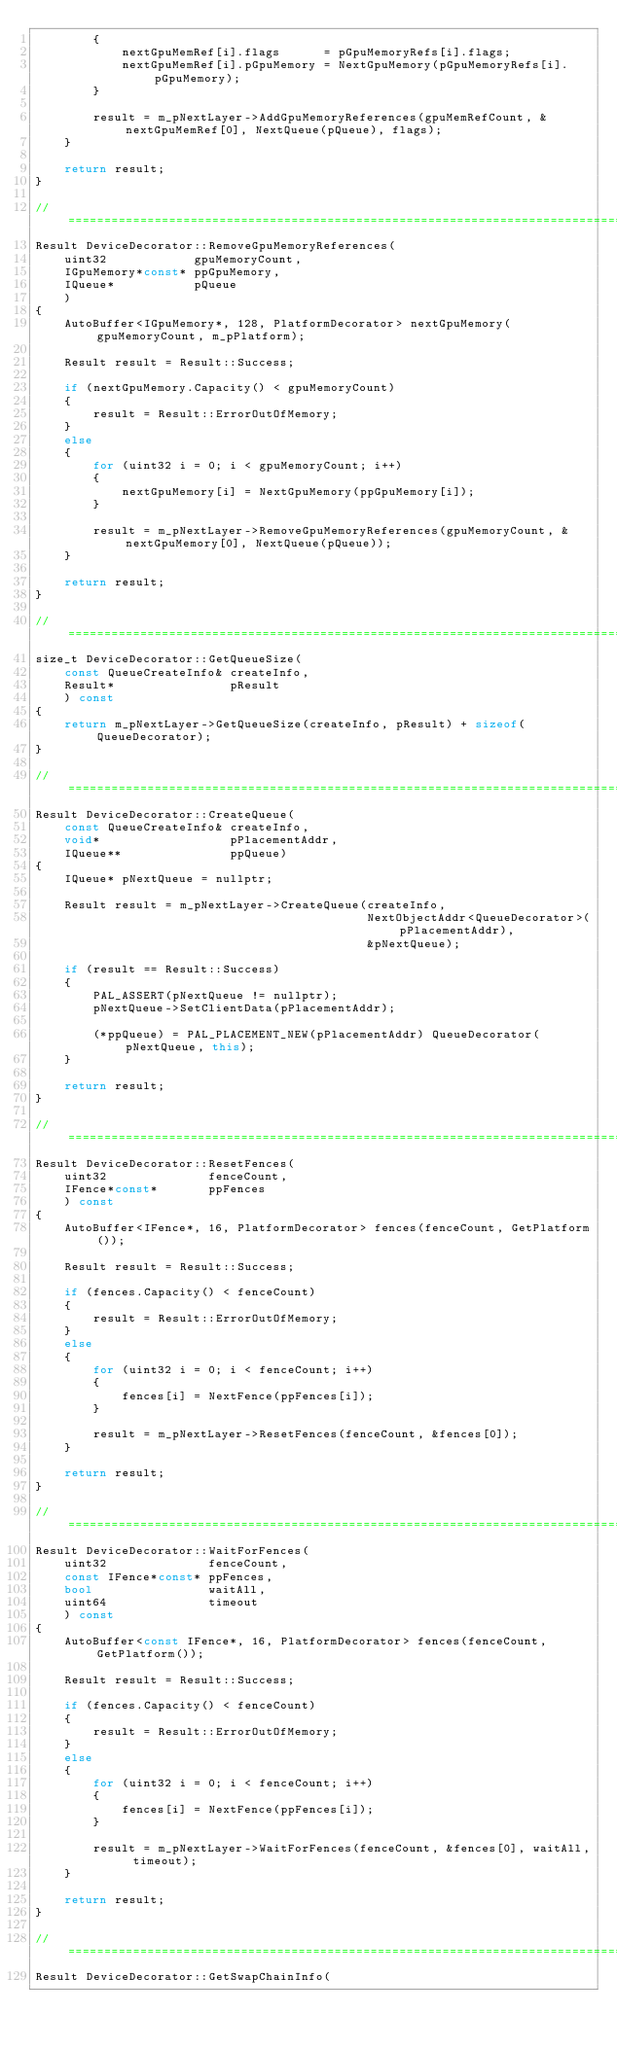Convert code to text. <code><loc_0><loc_0><loc_500><loc_500><_C++_>        {
            nextGpuMemRef[i].flags      = pGpuMemoryRefs[i].flags;
            nextGpuMemRef[i].pGpuMemory = NextGpuMemory(pGpuMemoryRefs[i].pGpuMemory);
        }

        result = m_pNextLayer->AddGpuMemoryReferences(gpuMemRefCount, &nextGpuMemRef[0], NextQueue(pQueue), flags);
    }

    return result;
}

// =====================================================================================================================
Result DeviceDecorator::RemoveGpuMemoryReferences(
    uint32            gpuMemoryCount,
    IGpuMemory*const* ppGpuMemory,
    IQueue*           pQueue
    )
{
    AutoBuffer<IGpuMemory*, 128, PlatformDecorator> nextGpuMemory(gpuMemoryCount, m_pPlatform);

    Result result = Result::Success;

    if (nextGpuMemory.Capacity() < gpuMemoryCount)
    {
        result = Result::ErrorOutOfMemory;
    }
    else
    {
        for (uint32 i = 0; i < gpuMemoryCount; i++)
        {
            nextGpuMemory[i] = NextGpuMemory(ppGpuMemory[i]);
        }

        result = m_pNextLayer->RemoveGpuMemoryReferences(gpuMemoryCount, &nextGpuMemory[0], NextQueue(pQueue));
    }

    return result;
}

// =====================================================================================================================
size_t DeviceDecorator::GetQueueSize(
    const QueueCreateInfo& createInfo,
    Result*                pResult
    ) const
{
    return m_pNextLayer->GetQueueSize(createInfo, pResult) + sizeof(QueueDecorator);
}

// =====================================================================================================================
Result DeviceDecorator::CreateQueue(
    const QueueCreateInfo& createInfo,
    void*                  pPlacementAddr,
    IQueue**               ppQueue)
{
    IQueue* pNextQueue = nullptr;

    Result result = m_pNextLayer->CreateQueue(createInfo,
                                              NextObjectAddr<QueueDecorator>(pPlacementAddr),
                                              &pNextQueue);

    if (result == Result::Success)
    {
        PAL_ASSERT(pNextQueue != nullptr);
        pNextQueue->SetClientData(pPlacementAddr);

        (*ppQueue) = PAL_PLACEMENT_NEW(pPlacementAddr) QueueDecorator(pNextQueue, this);
    }

    return result;
}

// =====================================================================================================================
Result DeviceDecorator::ResetFences(
    uint32              fenceCount,
    IFence*const*       ppFences
    ) const
{
    AutoBuffer<IFence*, 16, PlatformDecorator> fences(fenceCount, GetPlatform());

    Result result = Result::Success;

    if (fences.Capacity() < fenceCount)
    {
        result = Result::ErrorOutOfMemory;
    }
    else
    {
        for (uint32 i = 0; i < fenceCount; i++)
        {
            fences[i] = NextFence(ppFences[i]);
        }

        result = m_pNextLayer->ResetFences(fenceCount, &fences[0]);
    }

    return result;
}

// =====================================================================================================================
Result DeviceDecorator::WaitForFences(
    uint32              fenceCount,
    const IFence*const* ppFences,
    bool                waitAll,
    uint64              timeout
    ) const
{
    AutoBuffer<const IFence*, 16, PlatformDecorator> fences(fenceCount, GetPlatform());

    Result result = Result::Success;

    if (fences.Capacity() < fenceCount)
    {
        result = Result::ErrorOutOfMemory;
    }
    else
    {
        for (uint32 i = 0; i < fenceCount; i++)
        {
            fences[i] = NextFence(ppFences[i]);
        }

        result = m_pNextLayer->WaitForFences(fenceCount, &fences[0], waitAll, timeout);
    }

    return result;
}

// =====================================================================================================================
Result DeviceDecorator::GetSwapChainInfo(</code> 